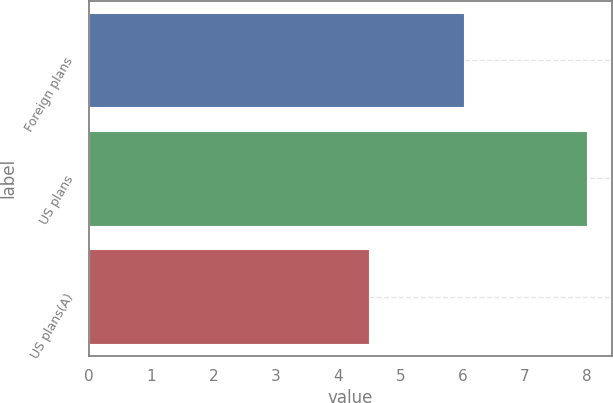Convert chart to OTSL. <chart><loc_0><loc_0><loc_500><loc_500><bar_chart><fcel>Foreign plans<fcel>US plans<fcel>US plans(A)<nl><fcel>6.03<fcel>8<fcel>4.5<nl></chart> 